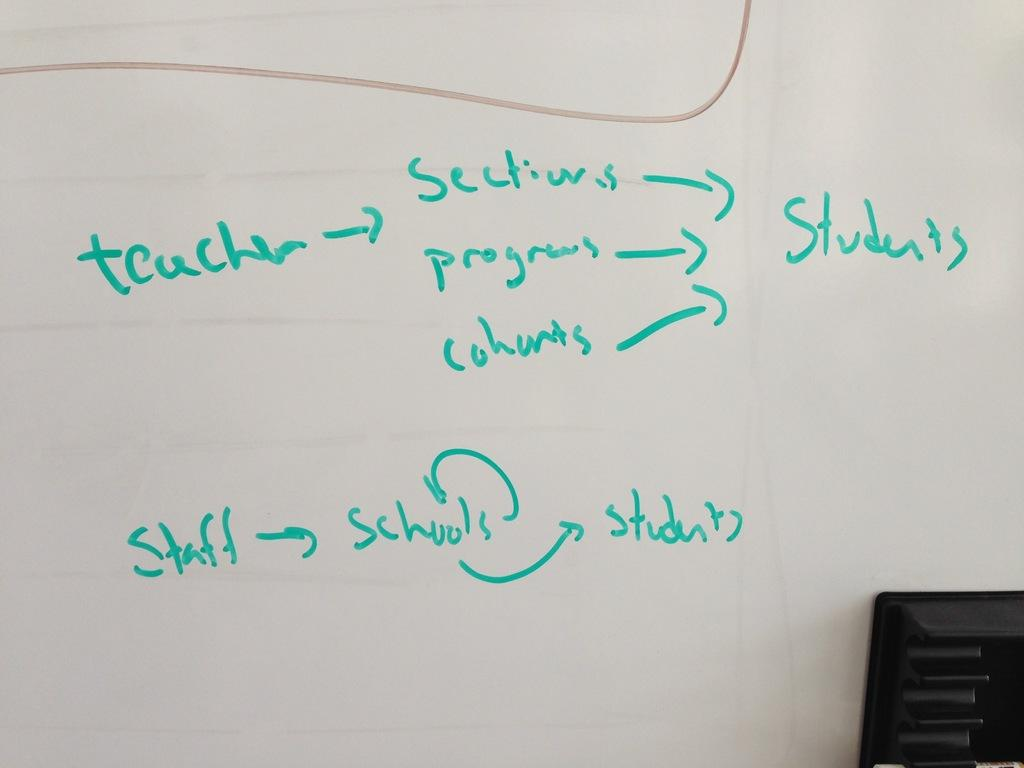Provide a one-sentence caption for the provided image. a write on wipe off board has a display of what teachers give to students. 